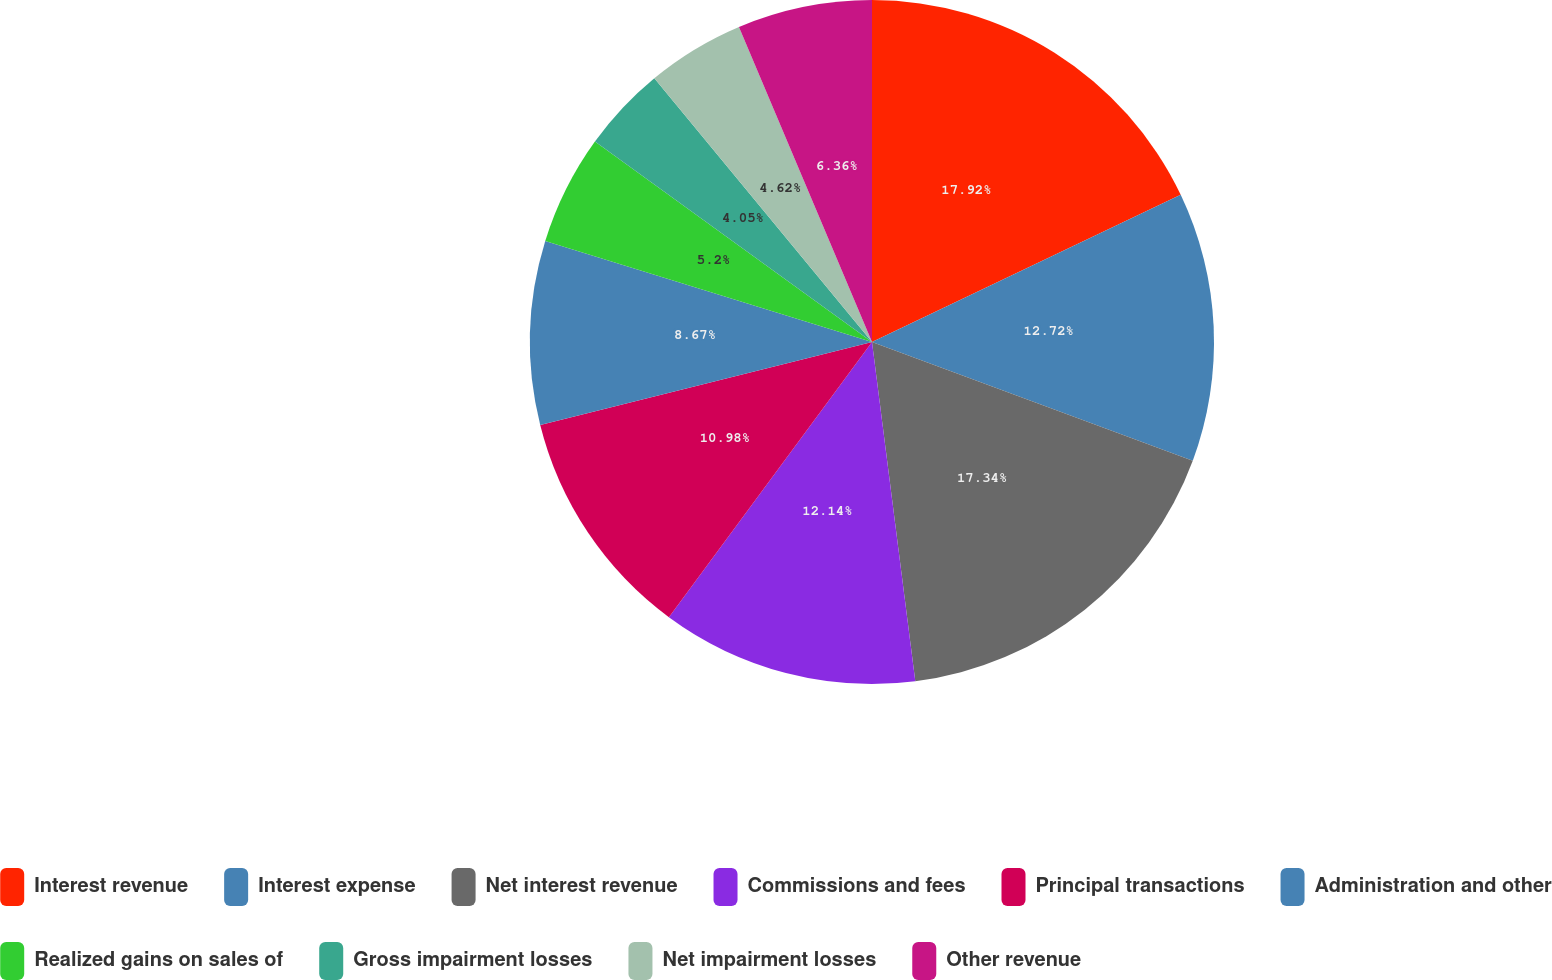Convert chart to OTSL. <chart><loc_0><loc_0><loc_500><loc_500><pie_chart><fcel>Interest revenue<fcel>Interest expense<fcel>Net interest revenue<fcel>Commissions and fees<fcel>Principal transactions<fcel>Administration and other<fcel>Realized gains on sales of<fcel>Gross impairment losses<fcel>Net impairment losses<fcel>Other revenue<nl><fcel>17.92%<fcel>12.72%<fcel>17.34%<fcel>12.14%<fcel>10.98%<fcel>8.67%<fcel>5.2%<fcel>4.05%<fcel>4.62%<fcel>6.36%<nl></chart> 